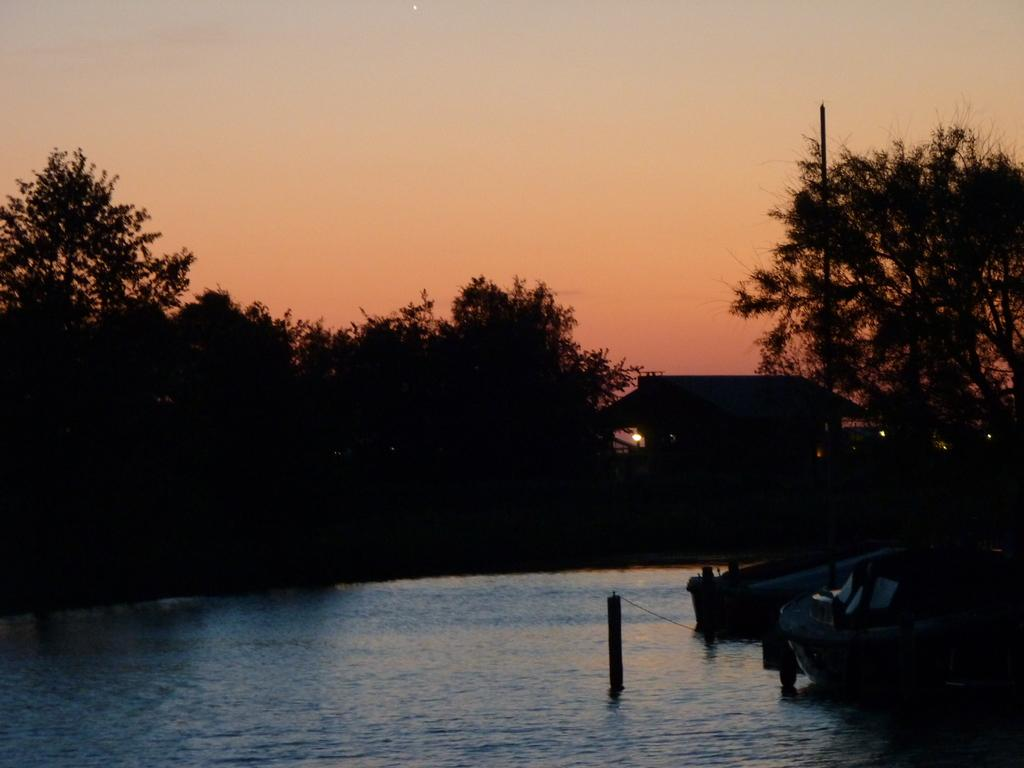What is the main feature of the image? The main feature of the image is a water surface. What can be seen on the right side of the water surface? There are boats on the right side of the water surface. What type of vegetation surrounds the water surface? There are trees surrounding the water surface. What type of cheese is being used to create bubbles in the water in the image? There is no cheese or bubbles present in the image; it features a water surface with boats and trees. 